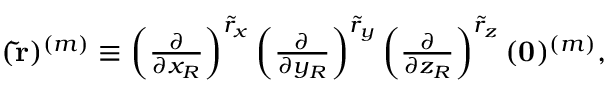<formula> <loc_0><loc_0><loc_500><loc_500>\begin{array} { r } { ( \tilde { r } ) ^ { ( m ) } \equiv \left ( \frac { \partial } { \partial x _ { R } } \right ) ^ { \tilde { r } _ { x } } \left ( \frac { \partial } { \partial y _ { R } } \right ) ^ { \tilde { r } _ { y } } \left ( \frac { \partial } { \partial z _ { R } } \right ) ^ { \tilde { r } _ { z } } ( 0 ) ^ { ( m ) } , } \end{array}</formula> 